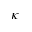<formula> <loc_0><loc_0><loc_500><loc_500>\kappa</formula> 